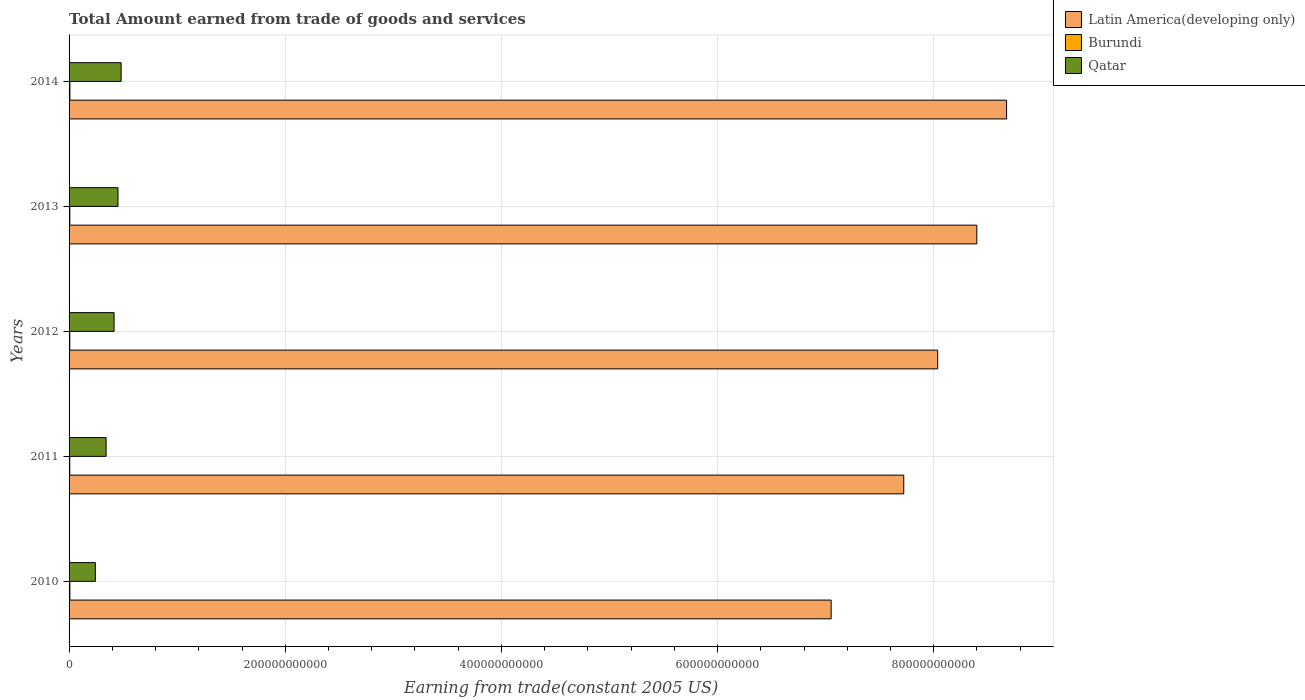Are the number of bars on each tick of the Y-axis equal?
Offer a very short reply. Yes. In how many cases, is the number of bars for a given year not equal to the number of legend labels?
Make the answer very short. 0. What is the total amount earned by trading goods and services in Qatar in 2010?
Your answer should be compact. 2.43e+1. Across all years, what is the maximum total amount earned by trading goods and services in Burundi?
Your response must be concise. 7.56e+08. Across all years, what is the minimum total amount earned by trading goods and services in Burundi?
Make the answer very short. 6.37e+08. In which year was the total amount earned by trading goods and services in Latin America(developing only) minimum?
Keep it short and to the point. 2010. What is the total total amount earned by trading goods and services in Burundi in the graph?
Offer a terse response. 3.52e+09. What is the difference between the total amount earned by trading goods and services in Latin America(developing only) in 2013 and that in 2014?
Offer a very short reply. -2.75e+1. What is the difference between the total amount earned by trading goods and services in Qatar in 2013 and the total amount earned by trading goods and services in Burundi in 2012?
Provide a short and direct response. 4.46e+1. What is the average total amount earned by trading goods and services in Qatar per year?
Your answer should be compact. 3.87e+1. In the year 2013, what is the difference between the total amount earned by trading goods and services in Qatar and total amount earned by trading goods and services in Latin America(developing only)?
Your response must be concise. -7.95e+11. In how many years, is the total amount earned by trading goods and services in Qatar greater than 720000000000 US$?
Provide a short and direct response. 0. What is the ratio of the total amount earned by trading goods and services in Latin America(developing only) in 2011 to that in 2012?
Provide a short and direct response. 0.96. Is the total amount earned by trading goods and services in Latin America(developing only) in 2010 less than that in 2011?
Offer a very short reply. Yes. Is the difference between the total amount earned by trading goods and services in Qatar in 2013 and 2014 greater than the difference between the total amount earned by trading goods and services in Latin America(developing only) in 2013 and 2014?
Offer a terse response. Yes. What is the difference between the highest and the second highest total amount earned by trading goods and services in Burundi?
Offer a terse response. 9.60e+06. What is the difference between the highest and the lowest total amount earned by trading goods and services in Burundi?
Give a very brief answer. 1.18e+08. What does the 3rd bar from the top in 2011 represents?
Give a very brief answer. Latin America(developing only). What does the 2nd bar from the bottom in 2012 represents?
Offer a very short reply. Burundi. What is the difference between two consecutive major ticks on the X-axis?
Provide a short and direct response. 2.00e+11. Does the graph contain any zero values?
Make the answer very short. No. Where does the legend appear in the graph?
Your response must be concise. Top right. How many legend labels are there?
Your answer should be very brief. 3. What is the title of the graph?
Give a very brief answer. Total Amount earned from trade of goods and services. What is the label or title of the X-axis?
Offer a terse response. Earning from trade(constant 2005 US). What is the label or title of the Y-axis?
Make the answer very short. Years. What is the Earning from trade(constant 2005 US) in Latin America(developing only) in 2010?
Ensure brevity in your answer.  7.05e+11. What is the Earning from trade(constant 2005 US) of Burundi in 2010?
Your answer should be very brief. 7.46e+08. What is the Earning from trade(constant 2005 US) in Qatar in 2010?
Ensure brevity in your answer.  2.43e+1. What is the Earning from trade(constant 2005 US) of Latin America(developing only) in 2011?
Give a very brief answer. 7.72e+11. What is the Earning from trade(constant 2005 US) of Burundi in 2011?
Provide a succinct answer. 6.37e+08. What is the Earning from trade(constant 2005 US) of Qatar in 2011?
Your response must be concise. 3.43e+1. What is the Earning from trade(constant 2005 US) in Latin America(developing only) in 2012?
Your answer should be compact. 8.04e+11. What is the Earning from trade(constant 2005 US) of Burundi in 2012?
Your answer should be very brief. 6.66e+08. What is the Earning from trade(constant 2005 US) in Qatar in 2012?
Your response must be concise. 4.16e+1. What is the Earning from trade(constant 2005 US) of Latin America(developing only) in 2013?
Your response must be concise. 8.40e+11. What is the Earning from trade(constant 2005 US) in Burundi in 2013?
Offer a very short reply. 7.20e+08. What is the Earning from trade(constant 2005 US) in Qatar in 2013?
Make the answer very short. 4.53e+1. What is the Earning from trade(constant 2005 US) of Latin America(developing only) in 2014?
Make the answer very short. 8.67e+11. What is the Earning from trade(constant 2005 US) in Burundi in 2014?
Keep it short and to the point. 7.56e+08. What is the Earning from trade(constant 2005 US) of Qatar in 2014?
Your response must be concise. 4.82e+1. Across all years, what is the maximum Earning from trade(constant 2005 US) of Latin America(developing only)?
Provide a succinct answer. 8.67e+11. Across all years, what is the maximum Earning from trade(constant 2005 US) in Burundi?
Give a very brief answer. 7.56e+08. Across all years, what is the maximum Earning from trade(constant 2005 US) of Qatar?
Provide a short and direct response. 4.82e+1. Across all years, what is the minimum Earning from trade(constant 2005 US) in Latin America(developing only)?
Your answer should be compact. 7.05e+11. Across all years, what is the minimum Earning from trade(constant 2005 US) of Burundi?
Keep it short and to the point. 6.37e+08. Across all years, what is the minimum Earning from trade(constant 2005 US) in Qatar?
Give a very brief answer. 2.43e+1. What is the total Earning from trade(constant 2005 US) of Latin America(developing only) in the graph?
Give a very brief answer. 3.99e+12. What is the total Earning from trade(constant 2005 US) of Burundi in the graph?
Give a very brief answer. 3.52e+09. What is the total Earning from trade(constant 2005 US) of Qatar in the graph?
Keep it short and to the point. 1.94e+11. What is the difference between the Earning from trade(constant 2005 US) in Latin America(developing only) in 2010 and that in 2011?
Your answer should be compact. -6.72e+1. What is the difference between the Earning from trade(constant 2005 US) in Burundi in 2010 and that in 2011?
Ensure brevity in your answer.  1.09e+08. What is the difference between the Earning from trade(constant 2005 US) in Qatar in 2010 and that in 2011?
Make the answer very short. -9.93e+09. What is the difference between the Earning from trade(constant 2005 US) in Latin America(developing only) in 2010 and that in 2012?
Offer a terse response. -9.86e+1. What is the difference between the Earning from trade(constant 2005 US) in Burundi in 2010 and that in 2012?
Keep it short and to the point. 7.97e+07. What is the difference between the Earning from trade(constant 2005 US) of Qatar in 2010 and that in 2012?
Your response must be concise. -1.73e+1. What is the difference between the Earning from trade(constant 2005 US) of Latin America(developing only) in 2010 and that in 2013?
Provide a short and direct response. -1.35e+11. What is the difference between the Earning from trade(constant 2005 US) in Burundi in 2010 and that in 2013?
Give a very brief answer. 2.64e+07. What is the difference between the Earning from trade(constant 2005 US) in Qatar in 2010 and that in 2013?
Give a very brief answer. -2.09e+1. What is the difference between the Earning from trade(constant 2005 US) in Latin America(developing only) in 2010 and that in 2014?
Your answer should be compact. -1.62e+11. What is the difference between the Earning from trade(constant 2005 US) in Burundi in 2010 and that in 2014?
Give a very brief answer. -9.60e+06. What is the difference between the Earning from trade(constant 2005 US) in Qatar in 2010 and that in 2014?
Give a very brief answer. -2.38e+1. What is the difference between the Earning from trade(constant 2005 US) in Latin America(developing only) in 2011 and that in 2012?
Your answer should be very brief. -3.14e+1. What is the difference between the Earning from trade(constant 2005 US) in Burundi in 2011 and that in 2012?
Your answer should be very brief. -2.91e+07. What is the difference between the Earning from trade(constant 2005 US) in Qatar in 2011 and that in 2012?
Offer a very short reply. -7.38e+09. What is the difference between the Earning from trade(constant 2005 US) in Latin America(developing only) in 2011 and that in 2013?
Provide a succinct answer. -6.76e+1. What is the difference between the Earning from trade(constant 2005 US) in Burundi in 2011 and that in 2013?
Keep it short and to the point. -8.24e+07. What is the difference between the Earning from trade(constant 2005 US) of Qatar in 2011 and that in 2013?
Provide a succinct answer. -1.10e+1. What is the difference between the Earning from trade(constant 2005 US) in Latin America(developing only) in 2011 and that in 2014?
Make the answer very short. -9.51e+1. What is the difference between the Earning from trade(constant 2005 US) in Burundi in 2011 and that in 2014?
Provide a succinct answer. -1.18e+08. What is the difference between the Earning from trade(constant 2005 US) of Qatar in 2011 and that in 2014?
Give a very brief answer. -1.39e+1. What is the difference between the Earning from trade(constant 2005 US) in Latin America(developing only) in 2012 and that in 2013?
Offer a very short reply. -3.62e+1. What is the difference between the Earning from trade(constant 2005 US) of Burundi in 2012 and that in 2013?
Make the answer very short. -5.33e+07. What is the difference between the Earning from trade(constant 2005 US) of Qatar in 2012 and that in 2013?
Your answer should be compact. -3.62e+09. What is the difference between the Earning from trade(constant 2005 US) in Latin America(developing only) in 2012 and that in 2014?
Your answer should be very brief. -6.37e+1. What is the difference between the Earning from trade(constant 2005 US) in Burundi in 2012 and that in 2014?
Offer a terse response. -8.93e+07. What is the difference between the Earning from trade(constant 2005 US) in Qatar in 2012 and that in 2014?
Ensure brevity in your answer.  -6.53e+09. What is the difference between the Earning from trade(constant 2005 US) of Latin America(developing only) in 2013 and that in 2014?
Your response must be concise. -2.75e+1. What is the difference between the Earning from trade(constant 2005 US) of Burundi in 2013 and that in 2014?
Your response must be concise. -3.60e+07. What is the difference between the Earning from trade(constant 2005 US) of Qatar in 2013 and that in 2014?
Provide a short and direct response. -2.91e+09. What is the difference between the Earning from trade(constant 2005 US) in Latin America(developing only) in 2010 and the Earning from trade(constant 2005 US) in Burundi in 2011?
Provide a succinct answer. 7.04e+11. What is the difference between the Earning from trade(constant 2005 US) in Latin America(developing only) in 2010 and the Earning from trade(constant 2005 US) in Qatar in 2011?
Keep it short and to the point. 6.71e+11. What is the difference between the Earning from trade(constant 2005 US) in Burundi in 2010 and the Earning from trade(constant 2005 US) in Qatar in 2011?
Keep it short and to the point. -3.35e+1. What is the difference between the Earning from trade(constant 2005 US) of Latin America(developing only) in 2010 and the Earning from trade(constant 2005 US) of Burundi in 2012?
Make the answer very short. 7.04e+11. What is the difference between the Earning from trade(constant 2005 US) of Latin America(developing only) in 2010 and the Earning from trade(constant 2005 US) of Qatar in 2012?
Your response must be concise. 6.63e+11. What is the difference between the Earning from trade(constant 2005 US) of Burundi in 2010 and the Earning from trade(constant 2005 US) of Qatar in 2012?
Provide a short and direct response. -4.09e+1. What is the difference between the Earning from trade(constant 2005 US) of Latin America(developing only) in 2010 and the Earning from trade(constant 2005 US) of Burundi in 2013?
Your answer should be compact. 7.04e+11. What is the difference between the Earning from trade(constant 2005 US) of Latin America(developing only) in 2010 and the Earning from trade(constant 2005 US) of Qatar in 2013?
Provide a short and direct response. 6.60e+11. What is the difference between the Earning from trade(constant 2005 US) of Burundi in 2010 and the Earning from trade(constant 2005 US) of Qatar in 2013?
Offer a very short reply. -4.45e+1. What is the difference between the Earning from trade(constant 2005 US) in Latin America(developing only) in 2010 and the Earning from trade(constant 2005 US) in Burundi in 2014?
Ensure brevity in your answer.  7.04e+11. What is the difference between the Earning from trade(constant 2005 US) in Latin America(developing only) in 2010 and the Earning from trade(constant 2005 US) in Qatar in 2014?
Your response must be concise. 6.57e+11. What is the difference between the Earning from trade(constant 2005 US) of Burundi in 2010 and the Earning from trade(constant 2005 US) of Qatar in 2014?
Make the answer very short. -4.74e+1. What is the difference between the Earning from trade(constant 2005 US) in Latin America(developing only) in 2011 and the Earning from trade(constant 2005 US) in Burundi in 2012?
Offer a very short reply. 7.72e+11. What is the difference between the Earning from trade(constant 2005 US) of Latin America(developing only) in 2011 and the Earning from trade(constant 2005 US) of Qatar in 2012?
Give a very brief answer. 7.31e+11. What is the difference between the Earning from trade(constant 2005 US) in Burundi in 2011 and the Earning from trade(constant 2005 US) in Qatar in 2012?
Your response must be concise. -4.10e+1. What is the difference between the Earning from trade(constant 2005 US) in Latin America(developing only) in 2011 and the Earning from trade(constant 2005 US) in Burundi in 2013?
Make the answer very short. 7.72e+11. What is the difference between the Earning from trade(constant 2005 US) of Latin America(developing only) in 2011 and the Earning from trade(constant 2005 US) of Qatar in 2013?
Your answer should be very brief. 7.27e+11. What is the difference between the Earning from trade(constant 2005 US) of Burundi in 2011 and the Earning from trade(constant 2005 US) of Qatar in 2013?
Give a very brief answer. -4.46e+1. What is the difference between the Earning from trade(constant 2005 US) in Latin America(developing only) in 2011 and the Earning from trade(constant 2005 US) in Burundi in 2014?
Your answer should be compact. 7.72e+11. What is the difference between the Earning from trade(constant 2005 US) in Latin America(developing only) in 2011 and the Earning from trade(constant 2005 US) in Qatar in 2014?
Offer a very short reply. 7.24e+11. What is the difference between the Earning from trade(constant 2005 US) of Burundi in 2011 and the Earning from trade(constant 2005 US) of Qatar in 2014?
Ensure brevity in your answer.  -4.75e+1. What is the difference between the Earning from trade(constant 2005 US) of Latin America(developing only) in 2012 and the Earning from trade(constant 2005 US) of Burundi in 2013?
Your answer should be compact. 8.03e+11. What is the difference between the Earning from trade(constant 2005 US) in Latin America(developing only) in 2012 and the Earning from trade(constant 2005 US) in Qatar in 2013?
Offer a very short reply. 7.58e+11. What is the difference between the Earning from trade(constant 2005 US) of Burundi in 2012 and the Earning from trade(constant 2005 US) of Qatar in 2013?
Offer a terse response. -4.46e+1. What is the difference between the Earning from trade(constant 2005 US) in Latin America(developing only) in 2012 and the Earning from trade(constant 2005 US) in Burundi in 2014?
Offer a very short reply. 8.03e+11. What is the difference between the Earning from trade(constant 2005 US) of Latin America(developing only) in 2012 and the Earning from trade(constant 2005 US) of Qatar in 2014?
Provide a short and direct response. 7.56e+11. What is the difference between the Earning from trade(constant 2005 US) in Burundi in 2012 and the Earning from trade(constant 2005 US) in Qatar in 2014?
Provide a short and direct response. -4.75e+1. What is the difference between the Earning from trade(constant 2005 US) in Latin America(developing only) in 2013 and the Earning from trade(constant 2005 US) in Burundi in 2014?
Give a very brief answer. 8.39e+11. What is the difference between the Earning from trade(constant 2005 US) in Latin America(developing only) in 2013 and the Earning from trade(constant 2005 US) in Qatar in 2014?
Your answer should be very brief. 7.92e+11. What is the difference between the Earning from trade(constant 2005 US) in Burundi in 2013 and the Earning from trade(constant 2005 US) in Qatar in 2014?
Provide a succinct answer. -4.75e+1. What is the average Earning from trade(constant 2005 US) of Latin America(developing only) per year?
Provide a succinct answer. 7.98e+11. What is the average Earning from trade(constant 2005 US) of Burundi per year?
Your answer should be compact. 7.05e+08. What is the average Earning from trade(constant 2005 US) of Qatar per year?
Make the answer very short. 3.87e+1. In the year 2010, what is the difference between the Earning from trade(constant 2005 US) of Latin America(developing only) and Earning from trade(constant 2005 US) of Burundi?
Make the answer very short. 7.04e+11. In the year 2010, what is the difference between the Earning from trade(constant 2005 US) in Latin America(developing only) and Earning from trade(constant 2005 US) in Qatar?
Make the answer very short. 6.81e+11. In the year 2010, what is the difference between the Earning from trade(constant 2005 US) of Burundi and Earning from trade(constant 2005 US) of Qatar?
Your response must be concise. -2.36e+1. In the year 2011, what is the difference between the Earning from trade(constant 2005 US) in Latin America(developing only) and Earning from trade(constant 2005 US) in Burundi?
Your response must be concise. 7.72e+11. In the year 2011, what is the difference between the Earning from trade(constant 2005 US) of Latin America(developing only) and Earning from trade(constant 2005 US) of Qatar?
Keep it short and to the point. 7.38e+11. In the year 2011, what is the difference between the Earning from trade(constant 2005 US) in Burundi and Earning from trade(constant 2005 US) in Qatar?
Keep it short and to the point. -3.36e+1. In the year 2012, what is the difference between the Earning from trade(constant 2005 US) in Latin America(developing only) and Earning from trade(constant 2005 US) in Burundi?
Your response must be concise. 8.03e+11. In the year 2012, what is the difference between the Earning from trade(constant 2005 US) in Latin America(developing only) and Earning from trade(constant 2005 US) in Qatar?
Your response must be concise. 7.62e+11. In the year 2012, what is the difference between the Earning from trade(constant 2005 US) in Burundi and Earning from trade(constant 2005 US) in Qatar?
Make the answer very short. -4.10e+1. In the year 2013, what is the difference between the Earning from trade(constant 2005 US) of Latin America(developing only) and Earning from trade(constant 2005 US) of Burundi?
Make the answer very short. 8.39e+11. In the year 2013, what is the difference between the Earning from trade(constant 2005 US) of Latin America(developing only) and Earning from trade(constant 2005 US) of Qatar?
Offer a terse response. 7.95e+11. In the year 2013, what is the difference between the Earning from trade(constant 2005 US) of Burundi and Earning from trade(constant 2005 US) of Qatar?
Offer a very short reply. -4.45e+1. In the year 2014, what is the difference between the Earning from trade(constant 2005 US) in Latin America(developing only) and Earning from trade(constant 2005 US) in Burundi?
Your response must be concise. 8.67e+11. In the year 2014, what is the difference between the Earning from trade(constant 2005 US) in Latin America(developing only) and Earning from trade(constant 2005 US) in Qatar?
Your answer should be very brief. 8.19e+11. In the year 2014, what is the difference between the Earning from trade(constant 2005 US) in Burundi and Earning from trade(constant 2005 US) in Qatar?
Provide a succinct answer. -4.74e+1. What is the ratio of the Earning from trade(constant 2005 US) of Latin America(developing only) in 2010 to that in 2011?
Give a very brief answer. 0.91. What is the ratio of the Earning from trade(constant 2005 US) in Burundi in 2010 to that in 2011?
Your answer should be very brief. 1.17. What is the ratio of the Earning from trade(constant 2005 US) in Qatar in 2010 to that in 2011?
Keep it short and to the point. 0.71. What is the ratio of the Earning from trade(constant 2005 US) in Latin America(developing only) in 2010 to that in 2012?
Offer a very short reply. 0.88. What is the ratio of the Earning from trade(constant 2005 US) of Burundi in 2010 to that in 2012?
Keep it short and to the point. 1.12. What is the ratio of the Earning from trade(constant 2005 US) in Qatar in 2010 to that in 2012?
Offer a terse response. 0.58. What is the ratio of the Earning from trade(constant 2005 US) in Latin America(developing only) in 2010 to that in 2013?
Give a very brief answer. 0.84. What is the ratio of the Earning from trade(constant 2005 US) of Burundi in 2010 to that in 2013?
Your answer should be very brief. 1.04. What is the ratio of the Earning from trade(constant 2005 US) of Qatar in 2010 to that in 2013?
Your response must be concise. 0.54. What is the ratio of the Earning from trade(constant 2005 US) of Latin America(developing only) in 2010 to that in 2014?
Offer a very short reply. 0.81. What is the ratio of the Earning from trade(constant 2005 US) in Burundi in 2010 to that in 2014?
Give a very brief answer. 0.99. What is the ratio of the Earning from trade(constant 2005 US) in Qatar in 2010 to that in 2014?
Provide a short and direct response. 0.51. What is the ratio of the Earning from trade(constant 2005 US) in Latin America(developing only) in 2011 to that in 2012?
Offer a very short reply. 0.96. What is the ratio of the Earning from trade(constant 2005 US) in Burundi in 2011 to that in 2012?
Your answer should be compact. 0.96. What is the ratio of the Earning from trade(constant 2005 US) in Qatar in 2011 to that in 2012?
Your answer should be very brief. 0.82. What is the ratio of the Earning from trade(constant 2005 US) of Latin America(developing only) in 2011 to that in 2013?
Your response must be concise. 0.92. What is the ratio of the Earning from trade(constant 2005 US) of Burundi in 2011 to that in 2013?
Keep it short and to the point. 0.89. What is the ratio of the Earning from trade(constant 2005 US) in Qatar in 2011 to that in 2013?
Your answer should be compact. 0.76. What is the ratio of the Earning from trade(constant 2005 US) in Latin America(developing only) in 2011 to that in 2014?
Provide a short and direct response. 0.89. What is the ratio of the Earning from trade(constant 2005 US) in Burundi in 2011 to that in 2014?
Your response must be concise. 0.84. What is the ratio of the Earning from trade(constant 2005 US) of Qatar in 2011 to that in 2014?
Your response must be concise. 0.71. What is the ratio of the Earning from trade(constant 2005 US) in Latin America(developing only) in 2012 to that in 2013?
Keep it short and to the point. 0.96. What is the ratio of the Earning from trade(constant 2005 US) of Burundi in 2012 to that in 2013?
Offer a very short reply. 0.93. What is the ratio of the Earning from trade(constant 2005 US) of Latin America(developing only) in 2012 to that in 2014?
Keep it short and to the point. 0.93. What is the ratio of the Earning from trade(constant 2005 US) of Burundi in 2012 to that in 2014?
Make the answer very short. 0.88. What is the ratio of the Earning from trade(constant 2005 US) of Qatar in 2012 to that in 2014?
Give a very brief answer. 0.86. What is the ratio of the Earning from trade(constant 2005 US) of Latin America(developing only) in 2013 to that in 2014?
Provide a succinct answer. 0.97. What is the ratio of the Earning from trade(constant 2005 US) in Burundi in 2013 to that in 2014?
Provide a short and direct response. 0.95. What is the ratio of the Earning from trade(constant 2005 US) in Qatar in 2013 to that in 2014?
Your response must be concise. 0.94. What is the difference between the highest and the second highest Earning from trade(constant 2005 US) in Latin America(developing only)?
Make the answer very short. 2.75e+1. What is the difference between the highest and the second highest Earning from trade(constant 2005 US) in Burundi?
Provide a succinct answer. 9.60e+06. What is the difference between the highest and the second highest Earning from trade(constant 2005 US) of Qatar?
Keep it short and to the point. 2.91e+09. What is the difference between the highest and the lowest Earning from trade(constant 2005 US) of Latin America(developing only)?
Your response must be concise. 1.62e+11. What is the difference between the highest and the lowest Earning from trade(constant 2005 US) of Burundi?
Your answer should be very brief. 1.18e+08. What is the difference between the highest and the lowest Earning from trade(constant 2005 US) in Qatar?
Your answer should be very brief. 2.38e+1. 